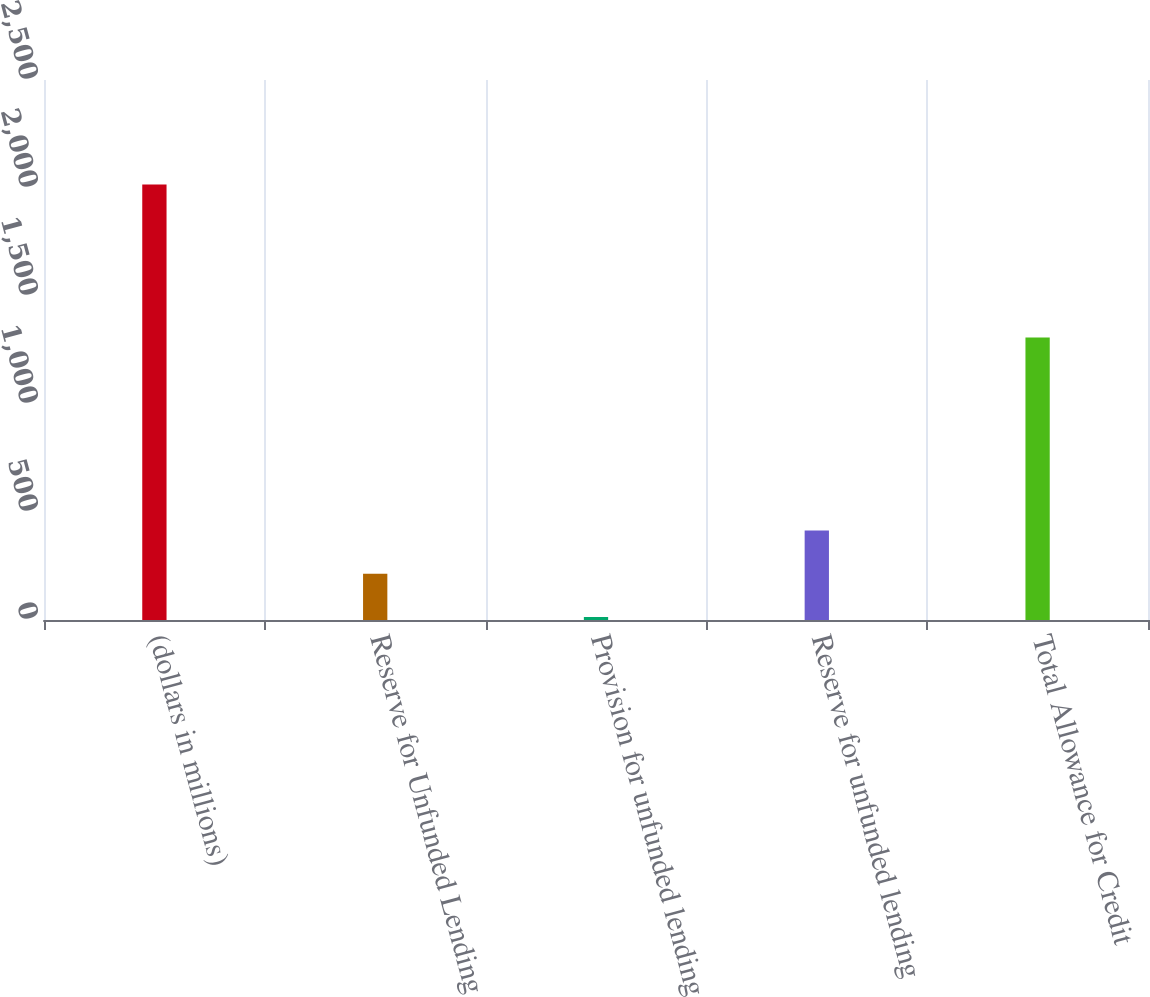Convert chart to OTSL. <chart><loc_0><loc_0><loc_500><loc_500><bar_chart><fcel>(dollars in millions)<fcel>Reserve for Unfunded Lending<fcel>Provision for unfunded lending<fcel>Reserve for unfunded lending<fcel>Total Allowance for Credit<nl><fcel>2016<fcel>214.2<fcel>14<fcel>414.4<fcel>1308<nl></chart> 